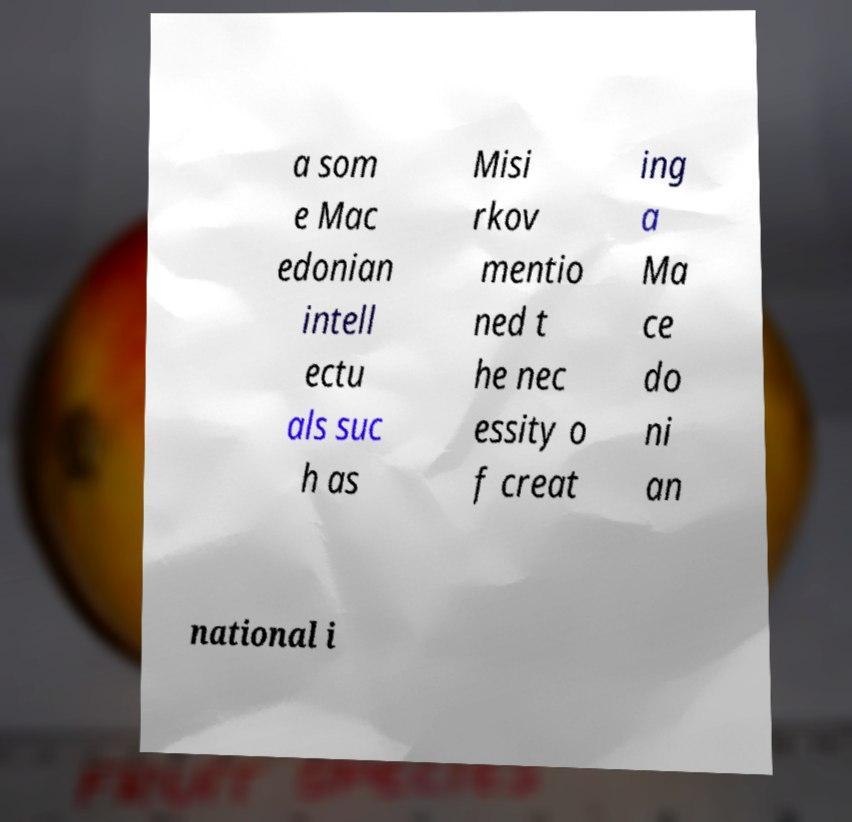Could you extract and type out the text from this image? a som e Mac edonian intell ectu als suc h as Misi rkov mentio ned t he nec essity o f creat ing a Ma ce do ni an national i 